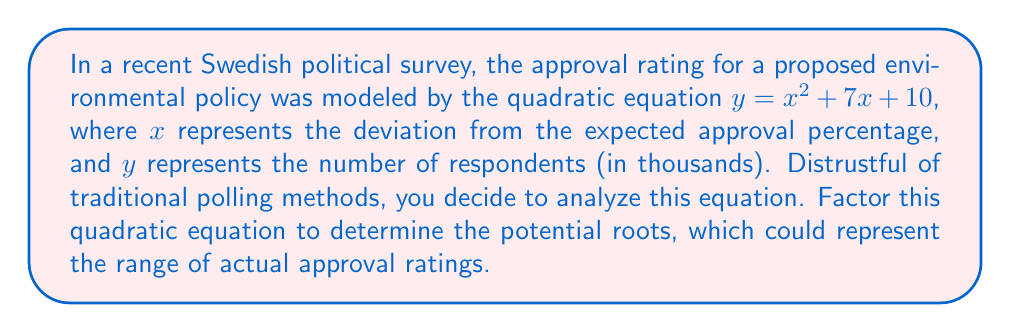Give your solution to this math problem. To factor this quadratic equation, we'll follow these steps:

1) First, identify the coefficients:
   $a = 1$, $b = 7$, $c = 10$

2) Look for two numbers that multiply to give $ac$ (which is 1 * 10 = 10) and add up to $b$ (which is 7).
   The numbers that satisfy this are 2 and 5.

3) Rewrite the middle term using these numbers:
   $y = x^2 + 2x + 5x + 10$

4) Group the terms:
   $y = (x^2 + 2x) + (5x + 10)$

5) Factor out the common factor from each group:
   $y = x(x + 2) + 5(x + 2)$

6) Notice that $(x + 2)$ is common to both terms. Factor it out:
   $y = (x + 5)(x + 2)$

Therefore, the factored form of the equation is $y = (x + 5)(x + 2)$.

The roots of this equation (where $y = 0$) are $x = -5$ and $x = -2$. In the context of the problem, this suggests that the actual approval rating could potentially deviate by -5 or -2 percentage points from the expected approval percentage.
Answer: $(x + 5)(x + 2)$ 